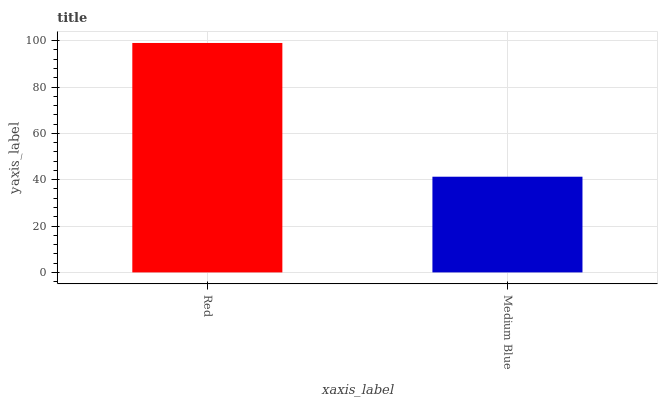Is Medium Blue the maximum?
Answer yes or no. No. Is Red greater than Medium Blue?
Answer yes or no. Yes. Is Medium Blue less than Red?
Answer yes or no. Yes. Is Medium Blue greater than Red?
Answer yes or no. No. Is Red less than Medium Blue?
Answer yes or no. No. Is Red the high median?
Answer yes or no. Yes. Is Medium Blue the low median?
Answer yes or no. Yes. Is Medium Blue the high median?
Answer yes or no. No. Is Red the low median?
Answer yes or no. No. 